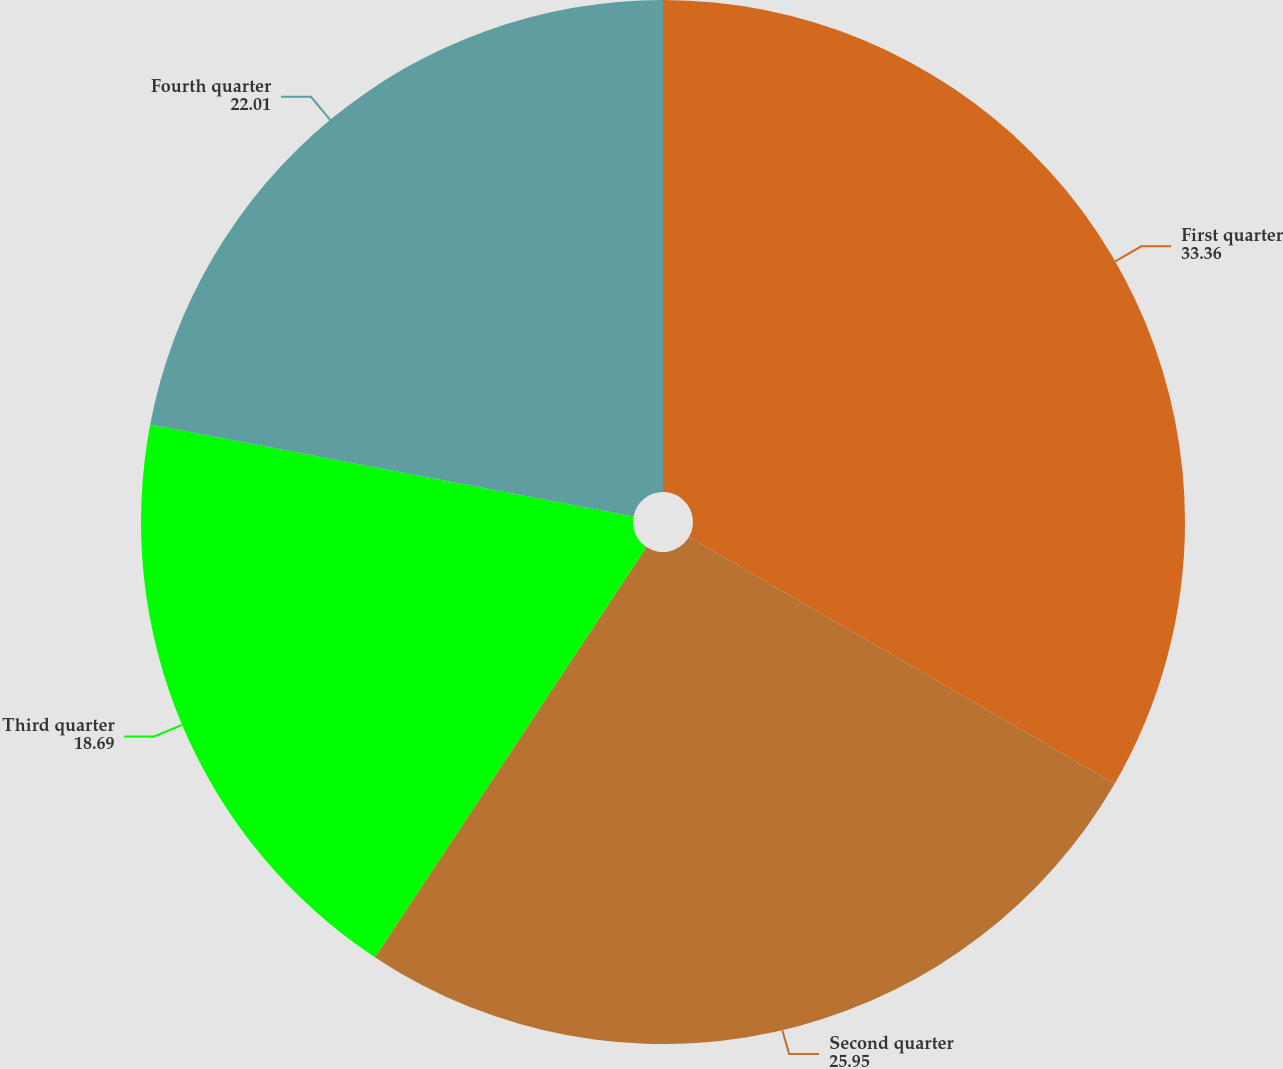<chart> <loc_0><loc_0><loc_500><loc_500><pie_chart><fcel>First quarter<fcel>Second quarter<fcel>Third quarter<fcel>Fourth quarter<nl><fcel>33.36%<fcel>25.95%<fcel>18.69%<fcel>22.01%<nl></chart> 